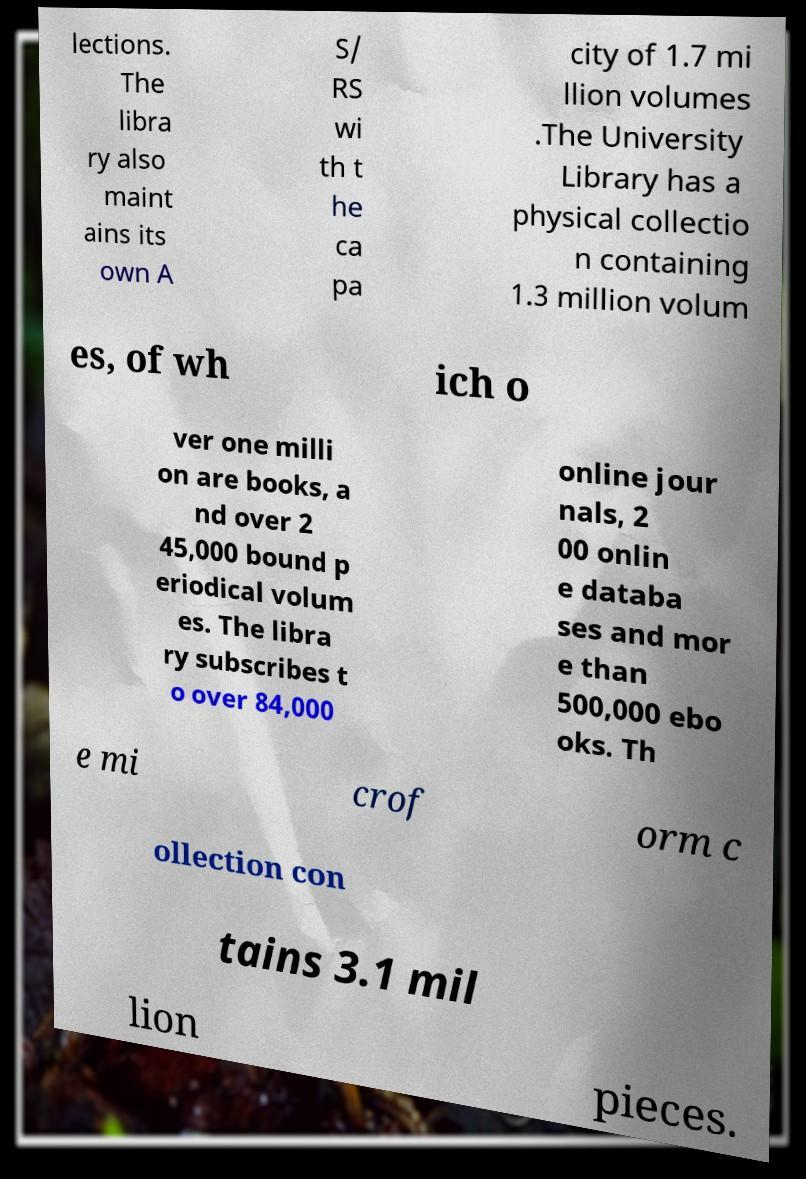There's text embedded in this image that I need extracted. Can you transcribe it verbatim? lections. The libra ry also maint ains its own A S/ RS wi th t he ca pa city of 1.7 mi llion volumes .The University Library has a physical collectio n containing 1.3 million volum es, of wh ich o ver one milli on are books, a nd over 2 45,000 bound p eriodical volum es. The libra ry subscribes t o over 84,000 online jour nals, 2 00 onlin e databa ses and mor e than 500,000 ebo oks. Th e mi crof orm c ollection con tains 3.1 mil lion pieces. 